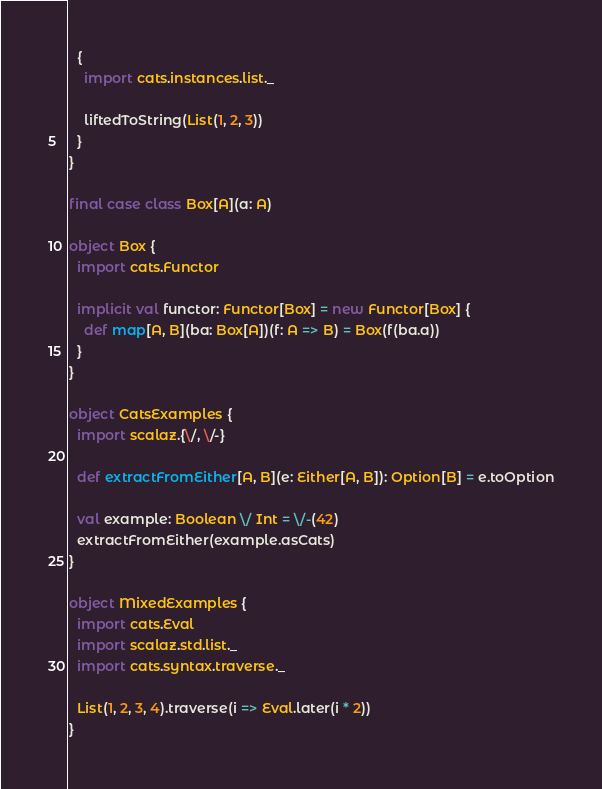<code> <loc_0><loc_0><loc_500><loc_500><_Scala_>
  {
    import cats.instances.list._

    liftedToString(List(1, 2, 3))
  }
}

final case class Box[A](a: A)

object Box {
  import cats.Functor

  implicit val functor: Functor[Box] = new Functor[Box] {
    def map[A, B](ba: Box[A])(f: A => B) = Box(f(ba.a))
  }
}

object CatsExamples {
  import scalaz.{\/, \/-}

  def extractFromEither[A, B](e: Either[A, B]): Option[B] = e.toOption

  val example: Boolean \/ Int = \/-(42)
  extractFromEither(example.asCats)
}

object MixedExamples {
  import cats.Eval
  import scalaz.std.list._
  import cats.syntax.traverse._

  List(1, 2, 3, 4).traverse(i => Eval.later(i * 2))
}
</code> 